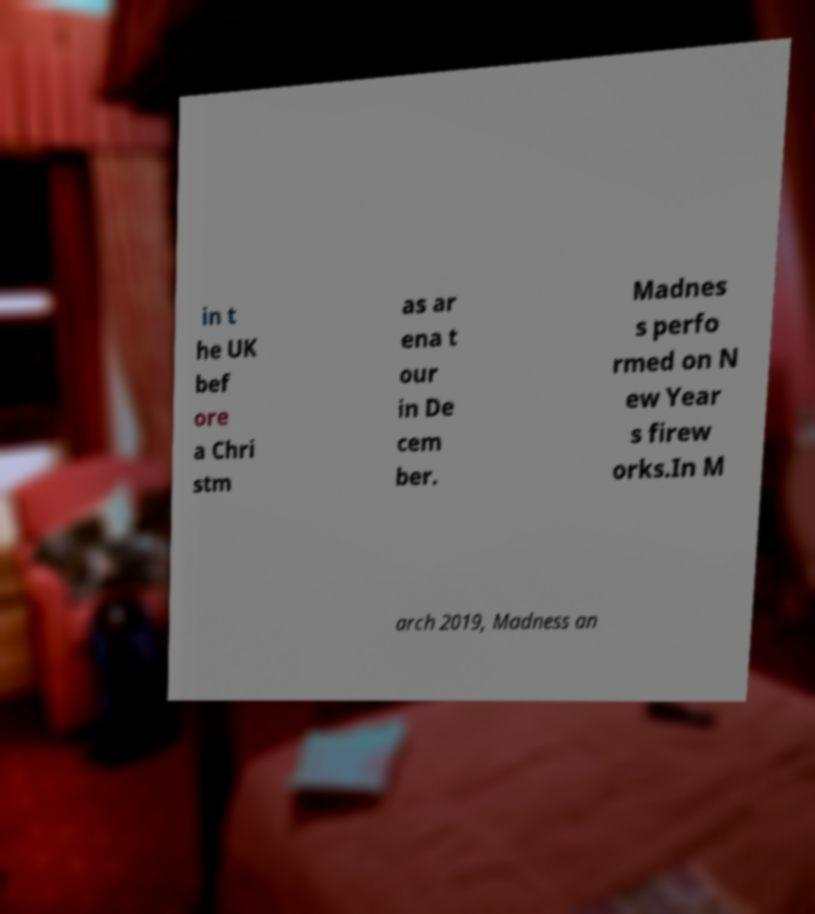I need the written content from this picture converted into text. Can you do that? in t he UK bef ore a Chri stm as ar ena t our in De cem ber. Madnes s perfo rmed on N ew Year s firew orks.In M arch 2019, Madness an 